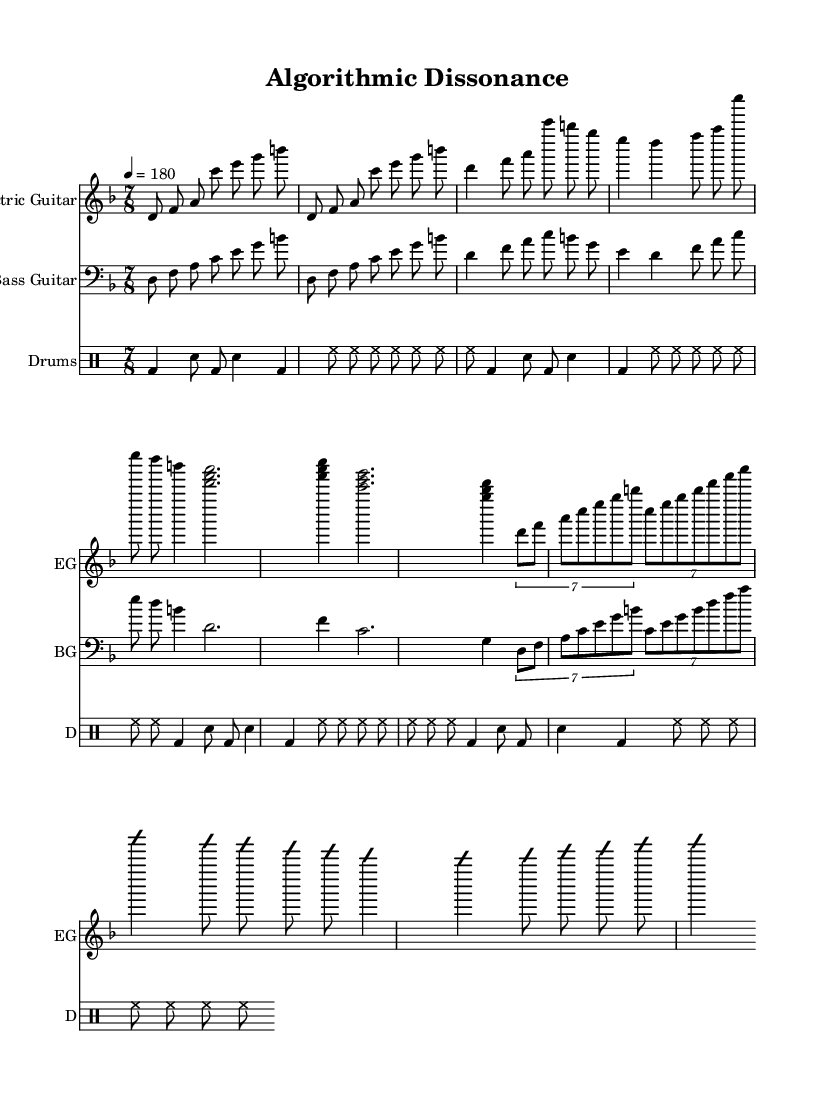What is the key signature of this music? The key signature is D minor, which has one flat (B♭). This can be determined by looking at the beginning of the piece just after the \key command which sets the key signature.
Answer: D minor What is the time signature of this sheet music? The time signature is 7/8. This notation appears in the first measure, indicating the piece is written in a compound meter with seven eighth notes per measure.
Answer: 7/8 What is the tempo marking in this score? The tempo marking is quarter note equals 180. This is found at the start under the \tempo command, which defines the speed of the music.
Answer: 180 How many times is the main riff repeated? The main riff is repeated 2 times. This information is indicated by the \repeat command in the electric guitar and bass guitar sections.
Answer: 2 What is the maximum number of notes that occur in the bridge section? The maximum number of notes in the bridge section is seven, as indicated by the tuplet notation which groups seven notes together within a 4/4 measure during the bridge.
Answer: 7 How many instruments are featured in this score? There are three instruments featured in this score: Electric Guitar, Bass Guitar, and Drums. This is evident from the separate staff lines for each instrument that are created in the score section of the LilyPond code.
Answer: 3 What genre does this composition belong to? The genre of this composition is Progressive Metal, as indicated by the title "Algorithmic Dissonance" and the use of complex time signatures, dissonant harmonies, and improvisation typical of the genre.
Answer: Progressive Metal 